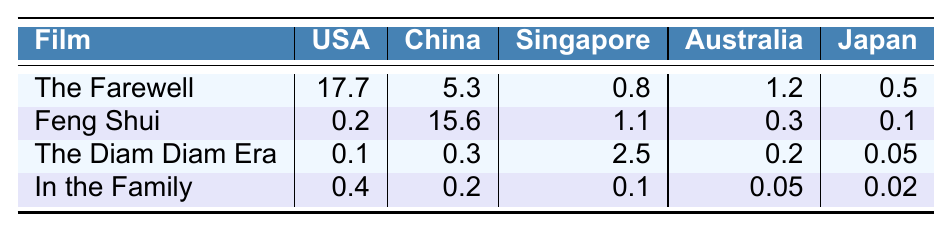What is the highest box office performance among Diana Lin's films in the USA? The highest box office performance in the USA is found in "The Farewell," which earned 17.7 million.
Answer: 17.7 million Which film made the least box office revenue in China? The film "In the Family" made the least box office revenue in China, earning 0.2 million, as it has the lowest value listed for that market.
Answer: 0.2 million What is the total box office revenue of "Feng Shui" across all markets? The total box office revenue of "Feng Shui" is calculated by adding its earnings: 0.2 (USA) + 15.6 (China) + 1.1 (Singapore) + 0.3 (Australia) + 0.1 (Japan) = 17.3 million.
Answer: 17.3 million Did "The Diam Diam Era" perform better in Singapore or Australia? "The Diam Diam Era" earned 2.5 million in Singapore and 0.2 million in Australia; since 2.5 is greater than 0.2, it performed better in Singapore.
Answer: Yes, better in Singapore What is the average box office revenue for "In the Family" across all markets? To calculate the average, sum the box office earnings of "In the Family": 0.4 (USA) + 0.2 (China) + 0.1 (Singapore) + 0.05 (Australia) + 0.02 (Japan) = 0.67 million. Divided by 5 (the number of markets), the average is 0.67 / 5 = 0.134 million.
Answer: 0.134 million Which film had a total box office revenue greater than 1 million in any market? "The Farewell" had a total of 17.7 million in the USA and 5.3 million in China, both exceeding 1 million, while "Feng Shui" also exceeded it in China with 15.6 million; thus, both films fall in this category.
Answer: Yes, "The Farewell" and "Feng Shui" What is the combined box office revenue for all films in Australia? The combined box office for Australia is found by adding each film's revenue: 1.2 (The Farewell) + 0.3 (Feng Shui) + 0.2 (The Diam Diam Era) + 0.05 (In the Family) = 1.75 million.
Answer: 1.75 million Is the total box office performance for "The Farewell" larger than the combined total for "The Diam Diam Era" and "In the Family"? "The Farewell" made 17.7 million, while "The Diam Diam Era" and "In the Family" combined made 0.1 + 0.4 = 0.5 million; since 17.7 is greater than 0.5, it is true.
Answer: Yes, it is larger 